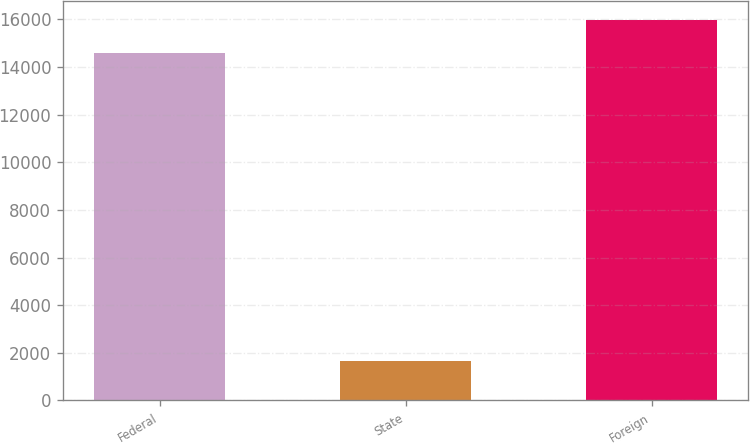<chart> <loc_0><loc_0><loc_500><loc_500><bar_chart><fcel>Federal<fcel>State<fcel>Foreign<nl><fcel>14609<fcel>1655<fcel>15987.2<nl></chart> 